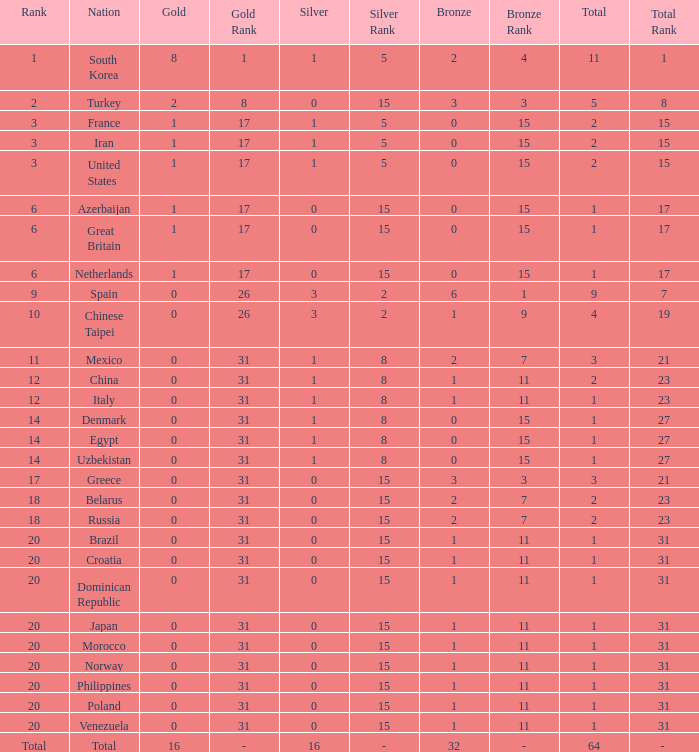What is the lowest number of gold medals the nation with less than 0 silver medals has? None. Give me the full table as a dictionary. {'header': ['Rank', 'Nation', 'Gold', 'Gold Rank', 'Silver', 'Silver Rank', 'Bronze', 'Bronze Rank', 'Total', 'Total Rank'], 'rows': [['1', 'South Korea', '8', '1', '1', '5', '2', '4', '11', '1'], ['2', 'Turkey', '2', '8', '0', '15', '3', '3', '5', '8'], ['3', 'France', '1', '17', '1', '5', '0', '15', '2', '15'], ['3', 'Iran', '1', '17', '1', '5', '0', '15', '2', '15'], ['3', 'United States', '1', '17', '1', '5', '0', '15', '2', '15'], ['6', 'Azerbaijan', '1', '17', '0', '15', '0', '15', '1', '17'], ['6', 'Great Britain', '1', '17', '0', '15', '0', '15', '1', '17'], ['6', 'Netherlands', '1', '17', '0', '15', '0', '15', '1', '17'], ['9', 'Spain', '0', '26', '3', '2', '6', '1', '9', '7'], ['10', 'Chinese Taipei', '0', '26', '3', '2', '1', '9', '4', '19'], ['11', 'Mexico', '0', '31', '1', '8', '2', '7', '3', '21'], ['12', 'China', '0', '31', '1', '8', '1', '11', '2', '23'], ['12', 'Italy', '0', '31', '1', '8', '1', '11', '1', '23'], ['14', 'Denmark', '0', '31', '1', '8', '0', '15', '1', '27'], ['14', 'Egypt', '0', '31', '1', '8', '0', '15', '1', '27'], ['14', 'Uzbekistan', '0', '31', '1', '8', '0', '15', '1', '27'], ['17', 'Greece', '0', '31', '0', '15', '3', '3', '3', '21'], ['18', 'Belarus', '0', '31', '0', '15', '2', '7', '2', '23'], ['18', 'Russia', '0', '31', '0', '15', '2', '7', '2', '23'], ['20', 'Brazil', '0', '31', '0', '15', '1', '11', '1', '31'], ['20', 'Croatia', '0', '31', '0', '15', '1', '11', '1', '31'], ['20', 'Dominican Republic', '0', '31', '0', '15', '1', '11', '1', '31'], ['20', 'Japan', '0', '31', '0', '15', '1', '11', '1', '31'], ['20', 'Morocco', '0', '31', '0', '15', '1', '11', '1', '31'], ['20', 'Norway', '0', '31', '0', '15', '1', '11', '1', '31'], ['20', 'Philippines', '0', '31', '0', '15', '1', '11', '1', '31'], ['20', 'Poland', '0', '31', '0', '15', '1', '11', '1', '31'], ['20', 'Venezuela', '0', '31', '0', '15', '1', '11', '1', '31'], ['Total', 'Total', '16', '-', '16', '-', '32', '-', '64', '- ']]} 